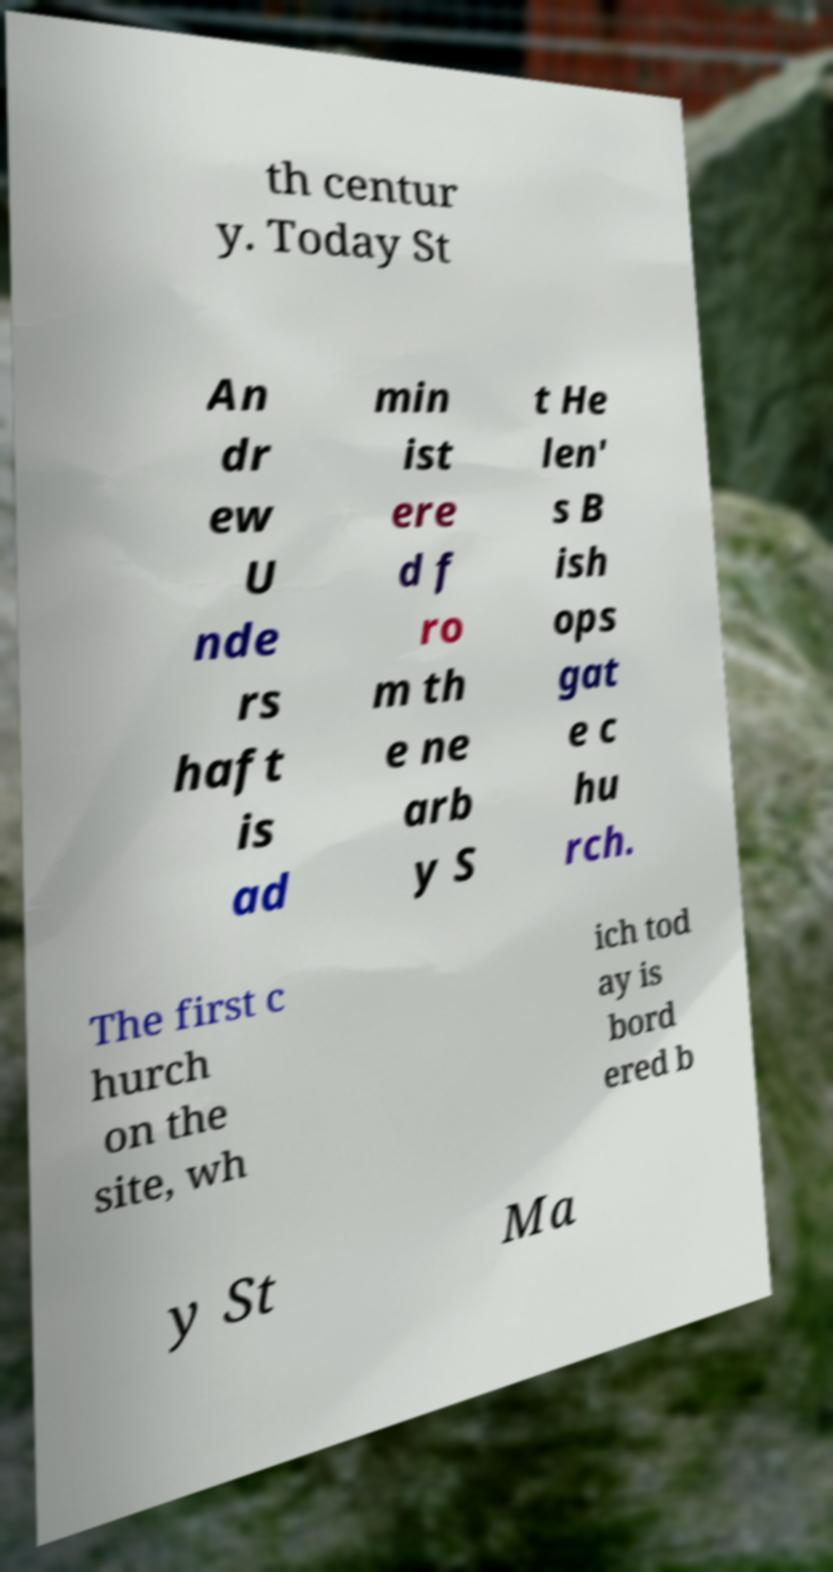Can you read and provide the text displayed in the image?This photo seems to have some interesting text. Can you extract and type it out for me? th centur y. Today St An dr ew U nde rs haft is ad min ist ere d f ro m th e ne arb y S t He len' s B ish ops gat e c hu rch. The first c hurch on the site, wh ich tod ay is bord ered b y St Ma 